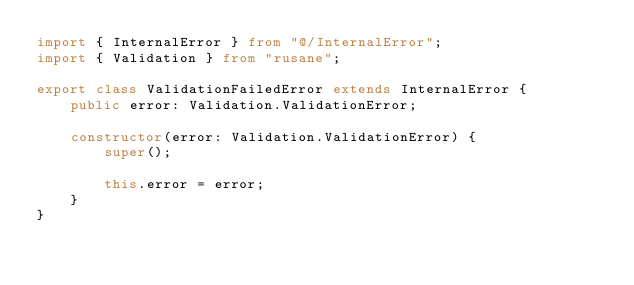Convert code to text. <code><loc_0><loc_0><loc_500><loc_500><_TypeScript_>import { InternalError } from "@/InternalError";
import { Validation } from "rusane";

export class ValidationFailedError extends InternalError {
    public error: Validation.ValidationError;

    constructor(error: Validation.ValidationError) {
        super();

        this.error = error;
    }
}
</code> 